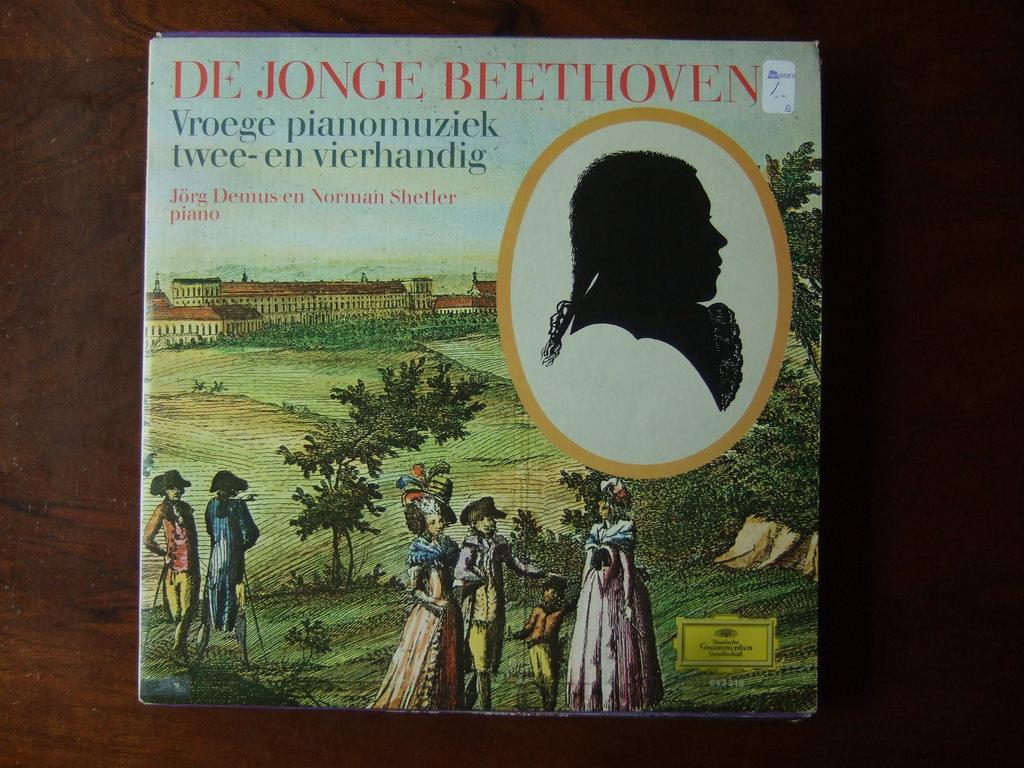Who is the composer of this album?
Ensure brevity in your answer.  De jonge beethoven. What does the blue text say?
Offer a terse response. Vroege pianomuziek twee-en vierhandig. 